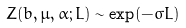Convert formula to latex. <formula><loc_0><loc_0><loc_500><loc_500>Z ( b , \mu , \alpha ; L ) \sim \exp ( - \sigma L )</formula> 